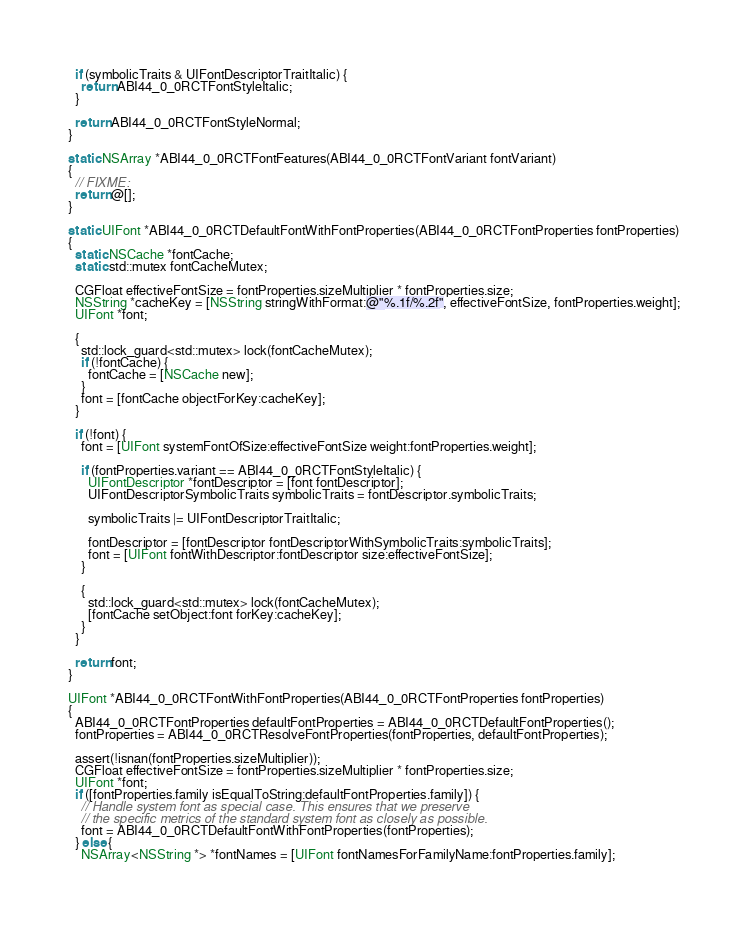<code> <loc_0><loc_0><loc_500><loc_500><_ObjectiveC_>  if (symbolicTraits & UIFontDescriptorTraitItalic) {
    return ABI44_0_0RCTFontStyleItalic;
  }

  return ABI44_0_0RCTFontStyleNormal;
}

static NSArray *ABI44_0_0RCTFontFeatures(ABI44_0_0RCTFontVariant fontVariant)
{
  // FIXME:
  return @[];
}

static UIFont *ABI44_0_0RCTDefaultFontWithFontProperties(ABI44_0_0RCTFontProperties fontProperties)
{
  static NSCache *fontCache;
  static std::mutex fontCacheMutex;

  CGFloat effectiveFontSize = fontProperties.sizeMultiplier * fontProperties.size;
  NSString *cacheKey = [NSString stringWithFormat:@"%.1f/%.2f", effectiveFontSize, fontProperties.weight];
  UIFont *font;

  {
    std::lock_guard<std::mutex> lock(fontCacheMutex);
    if (!fontCache) {
      fontCache = [NSCache new];
    }
    font = [fontCache objectForKey:cacheKey];
  }

  if (!font) {
    font = [UIFont systemFontOfSize:effectiveFontSize weight:fontProperties.weight];

    if (fontProperties.variant == ABI44_0_0RCTFontStyleItalic) {
      UIFontDescriptor *fontDescriptor = [font fontDescriptor];
      UIFontDescriptorSymbolicTraits symbolicTraits = fontDescriptor.symbolicTraits;

      symbolicTraits |= UIFontDescriptorTraitItalic;

      fontDescriptor = [fontDescriptor fontDescriptorWithSymbolicTraits:symbolicTraits];
      font = [UIFont fontWithDescriptor:fontDescriptor size:effectiveFontSize];
    }

    {
      std::lock_guard<std::mutex> lock(fontCacheMutex);
      [fontCache setObject:font forKey:cacheKey];
    }
  }

  return font;
}

UIFont *ABI44_0_0RCTFontWithFontProperties(ABI44_0_0RCTFontProperties fontProperties)
{
  ABI44_0_0RCTFontProperties defaultFontProperties = ABI44_0_0RCTDefaultFontProperties();
  fontProperties = ABI44_0_0RCTResolveFontProperties(fontProperties, defaultFontProperties);

  assert(!isnan(fontProperties.sizeMultiplier));
  CGFloat effectiveFontSize = fontProperties.sizeMultiplier * fontProperties.size;
  UIFont *font;
  if ([fontProperties.family isEqualToString:defaultFontProperties.family]) {
    // Handle system font as special case. This ensures that we preserve
    // the specific metrics of the standard system font as closely as possible.
    font = ABI44_0_0RCTDefaultFontWithFontProperties(fontProperties);
  } else {
    NSArray<NSString *> *fontNames = [UIFont fontNamesForFamilyName:fontProperties.family];
</code> 